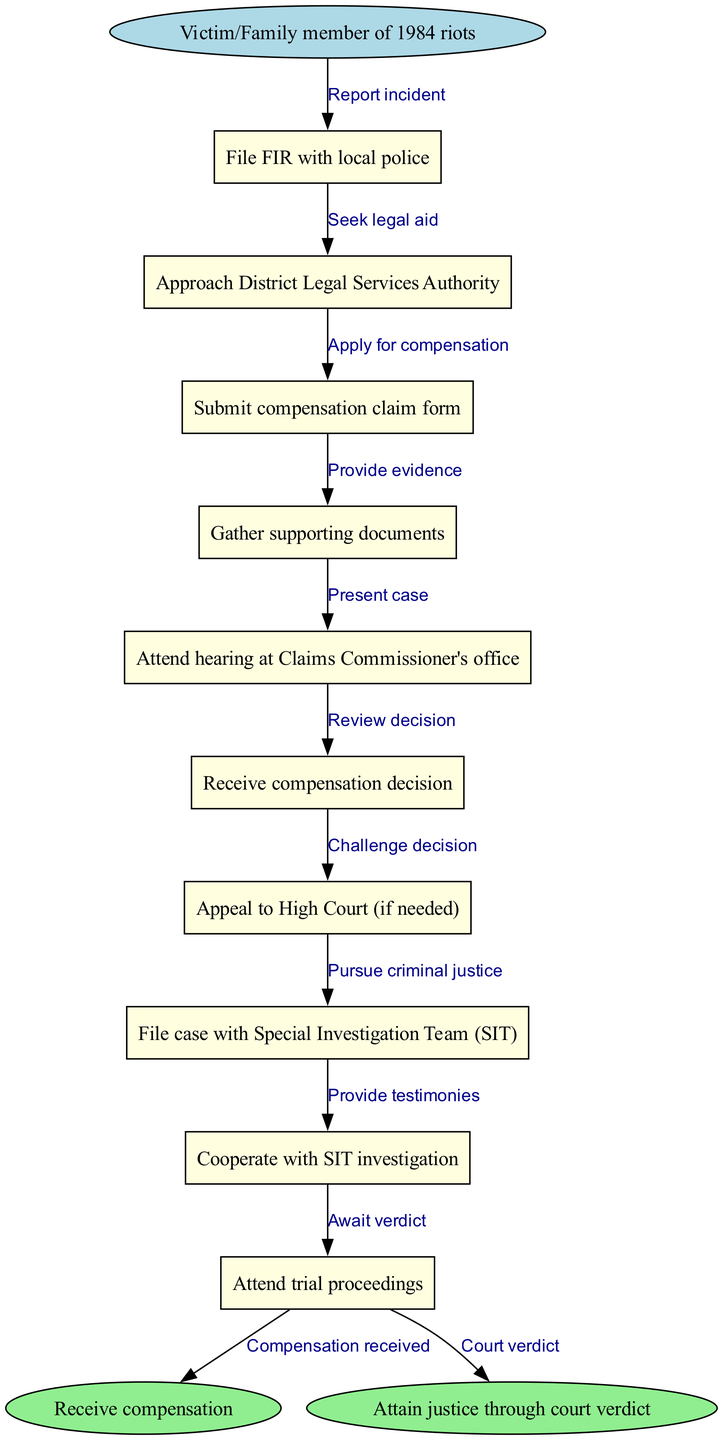What is the starting point in this legal process? The starting point is "Victim/Family member of 1984 riots." This is indicated as the first node in the diagram.
Answer: Victim/Family member of 1984 riots How many process nodes are depicted in the diagram? There are 10 process nodes, as listed in the "nodes" section of the data.
Answer: 10 What is the last process node before reaching an end node? The last process node is "Attend trial proceedings," which is the final step before either of the end nodes.
Answer: Attend trial proceedings What edge connects the start node to the first process node? The edge connecting the start node to the first process node is labeled "Report incident." This is shown as the first connection in the diagram.
Answer: Report incident What is the outcome if a victim receives compensation? If a victim receives compensation, the flow ends at the "Receive compensation" end node, as indicated in the diagram.
Answer: Receive compensation How many edges are there between the process nodes? There are 9 edges connecting the 10 process nodes, as each pair of consecutive nodes has one connecting edge.
Answer: 9 If a victim wants to challenge the compensation decision, which process do they follow? To challenge the compensation decision, the victim would "Appeal to High Court (if needed)" after receiving the compensation decision. This involves moving from its related node to that process.
Answer: Appeal to High Court Which node describes the criminal justice pursuit? The node that describes the criminal justice pursuit is "File case with Special Investigation Team (SIT)." It indicates a specific action towards pursuing justice.
Answer: File case with Special Investigation Team (SIT) What needs to be done after gathering supporting documents? After gathering supporting documents, a victim must "Attend hearing at Claims Commissioner's office," which is the next step in the diagram sequence.
Answer: Attend hearing at Claims Commissioner's office 